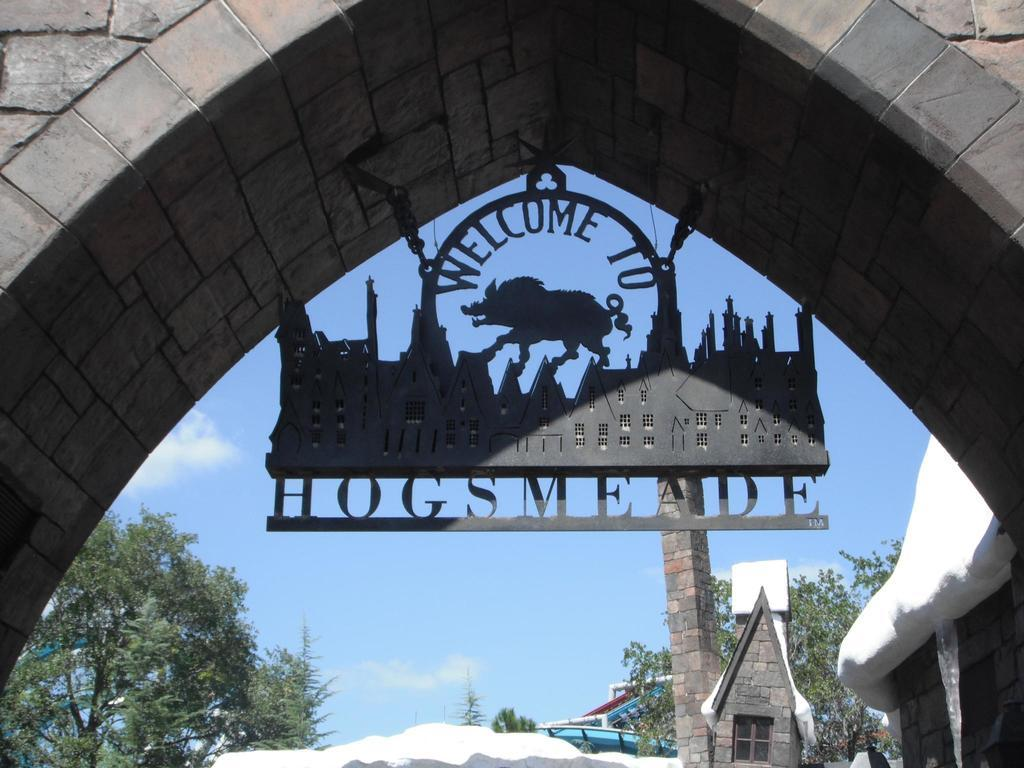What is the main subject in the center of the image? There is a welcome board in the center of the image. Where is the welcome board located? The welcome board is under an arch. What can be seen in the background of the image? There are houses, trees, and the sky visible in the background of the image. What is the weather like in the image? The presence of snow in the background suggests that it is snowing or has recently snowed. How many pins are attached to the woman's dress in the image? There is no woman present in the image, so it is not possible to determine how many pins might be attached to her dress. 